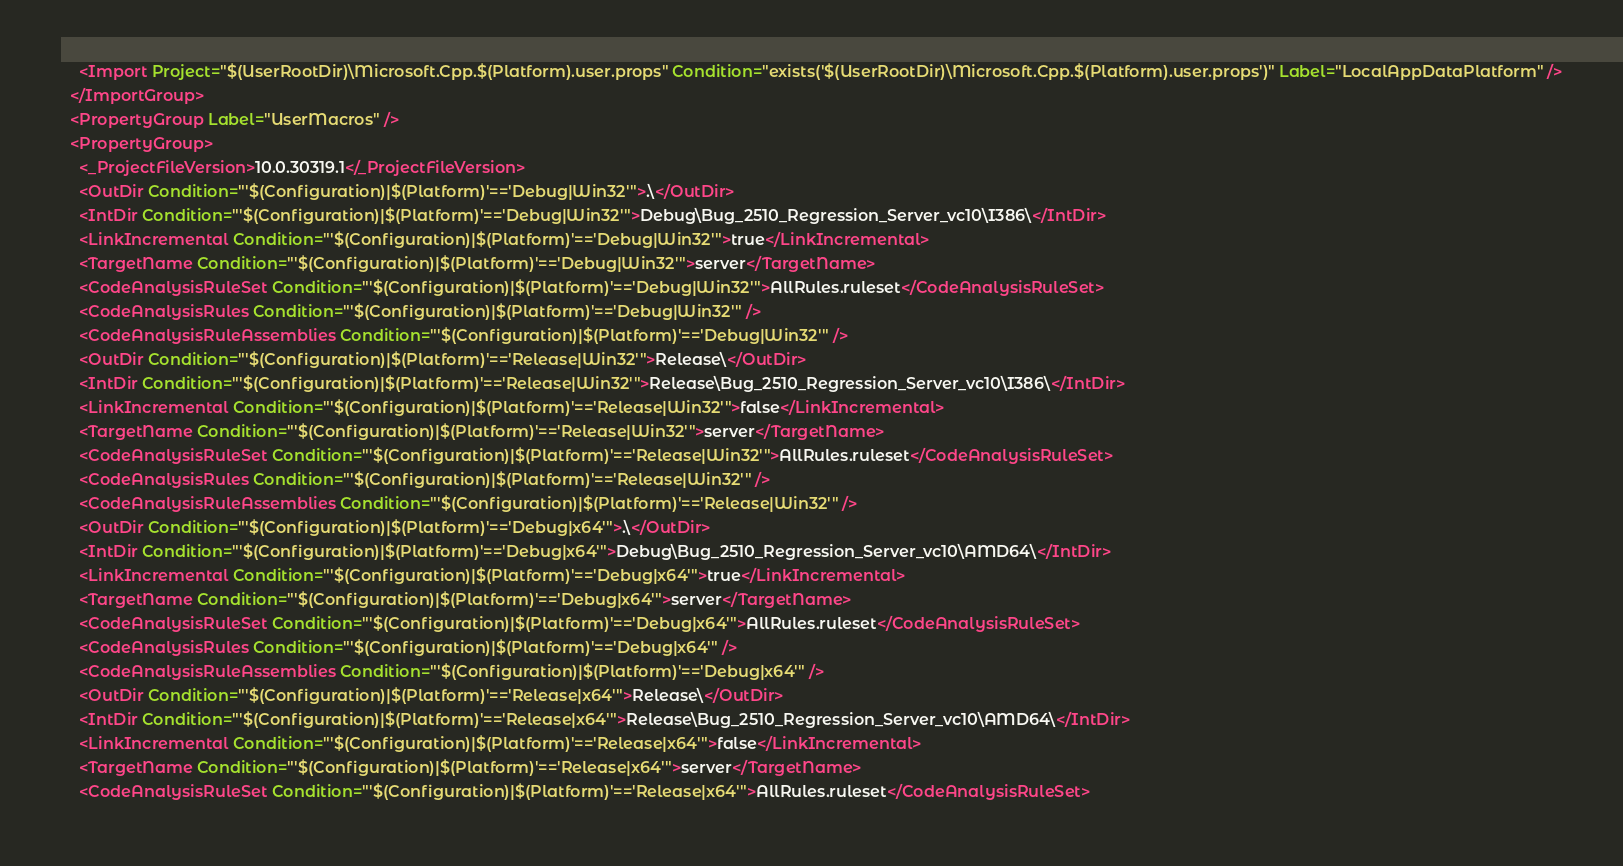<code> <loc_0><loc_0><loc_500><loc_500><_XML_>    <Import Project="$(UserRootDir)\Microsoft.Cpp.$(Platform).user.props" Condition="exists('$(UserRootDir)\Microsoft.Cpp.$(Platform).user.props')" Label="LocalAppDataPlatform" />
  </ImportGroup>
  <PropertyGroup Label="UserMacros" />
  <PropertyGroup>
    <_ProjectFileVersion>10.0.30319.1</_ProjectFileVersion>
    <OutDir Condition="'$(Configuration)|$(Platform)'=='Debug|Win32'">.\</OutDir>
    <IntDir Condition="'$(Configuration)|$(Platform)'=='Debug|Win32'">Debug\Bug_2510_Regression_Server_vc10\I386\</IntDir>
    <LinkIncremental Condition="'$(Configuration)|$(Platform)'=='Debug|Win32'">true</LinkIncremental>
    <TargetName Condition="'$(Configuration)|$(Platform)'=='Debug|Win32'">server</TargetName>
    <CodeAnalysisRuleSet Condition="'$(Configuration)|$(Platform)'=='Debug|Win32'">AllRules.ruleset</CodeAnalysisRuleSet>
    <CodeAnalysisRules Condition="'$(Configuration)|$(Platform)'=='Debug|Win32'" />
    <CodeAnalysisRuleAssemblies Condition="'$(Configuration)|$(Platform)'=='Debug|Win32'" />
    <OutDir Condition="'$(Configuration)|$(Platform)'=='Release|Win32'">Release\</OutDir>
    <IntDir Condition="'$(Configuration)|$(Platform)'=='Release|Win32'">Release\Bug_2510_Regression_Server_vc10\I386\</IntDir>
    <LinkIncremental Condition="'$(Configuration)|$(Platform)'=='Release|Win32'">false</LinkIncremental>
    <TargetName Condition="'$(Configuration)|$(Platform)'=='Release|Win32'">server</TargetName>
    <CodeAnalysisRuleSet Condition="'$(Configuration)|$(Platform)'=='Release|Win32'">AllRules.ruleset</CodeAnalysisRuleSet>
    <CodeAnalysisRules Condition="'$(Configuration)|$(Platform)'=='Release|Win32'" />
    <CodeAnalysisRuleAssemblies Condition="'$(Configuration)|$(Platform)'=='Release|Win32'" />
    <OutDir Condition="'$(Configuration)|$(Platform)'=='Debug|x64'">.\</OutDir>
    <IntDir Condition="'$(Configuration)|$(Platform)'=='Debug|x64'">Debug\Bug_2510_Regression_Server_vc10\AMD64\</IntDir>
    <LinkIncremental Condition="'$(Configuration)|$(Platform)'=='Debug|x64'">true</LinkIncremental>
    <TargetName Condition="'$(Configuration)|$(Platform)'=='Debug|x64'">server</TargetName>
    <CodeAnalysisRuleSet Condition="'$(Configuration)|$(Platform)'=='Debug|x64'">AllRules.ruleset</CodeAnalysisRuleSet>
    <CodeAnalysisRules Condition="'$(Configuration)|$(Platform)'=='Debug|x64'" />
    <CodeAnalysisRuleAssemblies Condition="'$(Configuration)|$(Platform)'=='Debug|x64'" />
    <OutDir Condition="'$(Configuration)|$(Platform)'=='Release|x64'">Release\</OutDir>
    <IntDir Condition="'$(Configuration)|$(Platform)'=='Release|x64'">Release\Bug_2510_Regression_Server_vc10\AMD64\</IntDir>
    <LinkIncremental Condition="'$(Configuration)|$(Platform)'=='Release|x64'">false</LinkIncremental>
    <TargetName Condition="'$(Configuration)|$(Platform)'=='Release|x64'">server</TargetName>
    <CodeAnalysisRuleSet Condition="'$(Configuration)|$(Platform)'=='Release|x64'">AllRules.ruleset</CodeAnalysisRuleSet></code> 